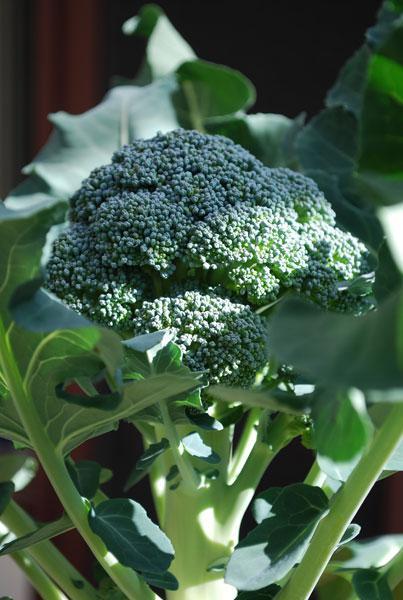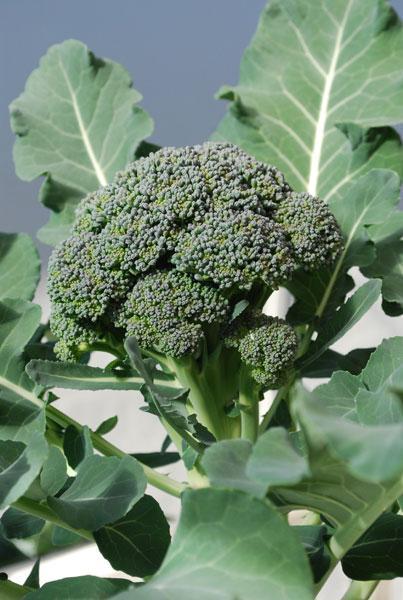The first image is the image on the left, the second image is the image on the right. Evaluate the accuracy of this statement regarding the images: "The left and right image contains the same number broccoli heads growing straight up.". Is it true? Answer yes or no. Yes. 